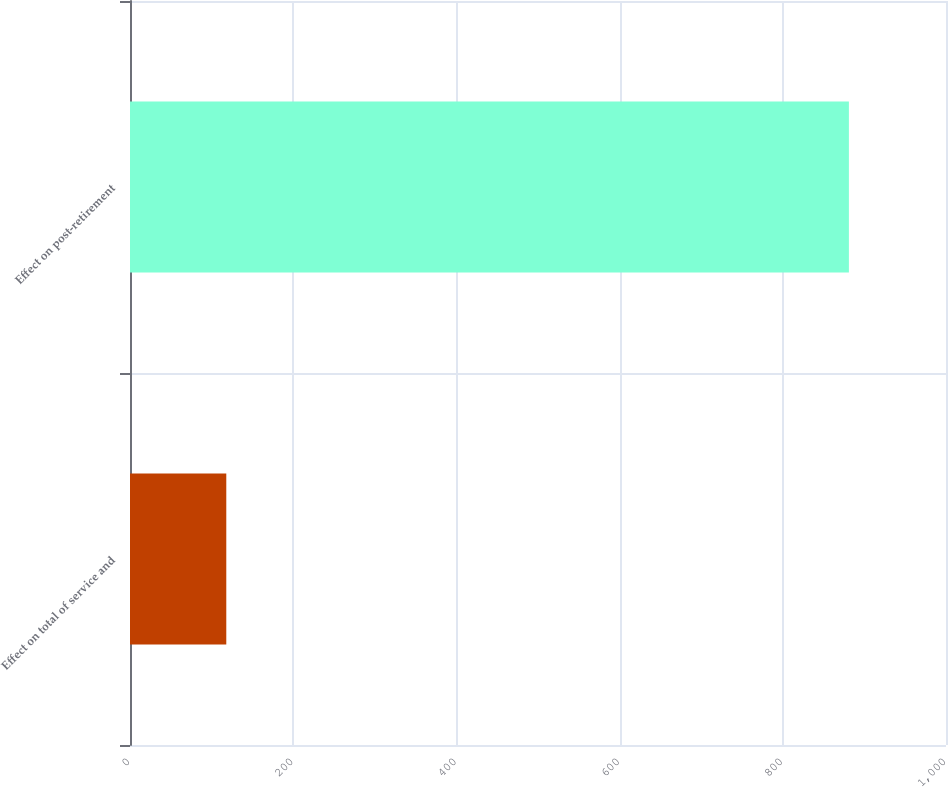Convert chart to OTSL. <chart><loc_0><loc_0><loc_500><loc_500><bar_chart><fcel>Effect on total of service and<fcel>Effect on post-retirement<nl><fcel>118<fcel>881<nl></chart> 